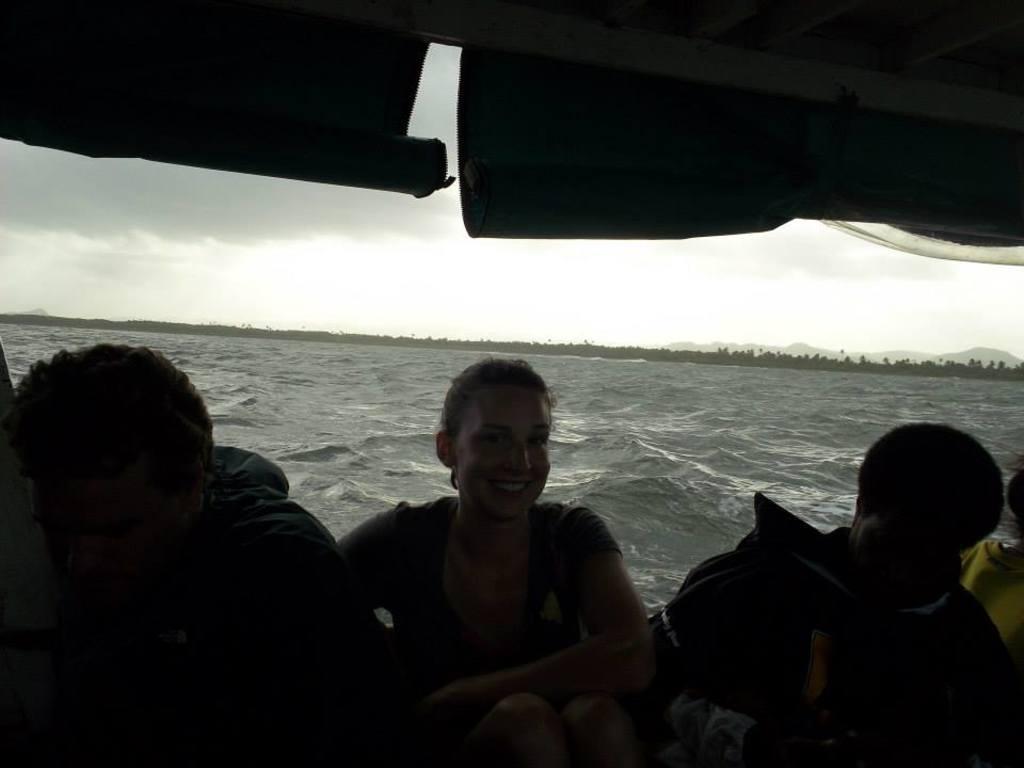How would you summarize this image in a sentence or two? In this picture there are some people sitting in the boat. There were men and women in this boat. In the background there is an ocean. We can observe trees, hills and a sky with some clouds. 